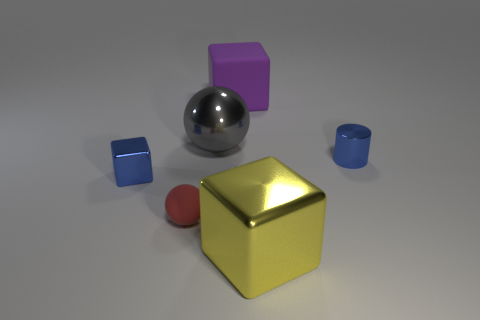Is the color of the shiny cylinder the same as the tiny metallic cube?
Your answer should be very brief. Yes. Are there an equal number of small red spheres that are right of the large yellow object and tiny red rubber objects?
Provide a short and direct response. No. Are there any big metallic spheres in front of the gray metal thing?
Your response must be concise. No. There is a large yellow metal thing; does it have the same shape as the tiny metallic thing that is on the right side of the big purple cube?
Your answer should be very brief. No. The large object that is the same material as the tiny red thing is what color?
Your answer should be very brief. Purple. What color is the small metal cylinder?
Your answer should be very brief. Blue. Does the blue block have the same material as the big yellow cube to the right of the metal ball?
Your response must be concise. Yes. How many objects are in front of the blue block and behind the big yellow shiny block?
Your answer should be very brief. 1. What shape is the red rubber object that is the same size as the blue shiny block?
Offer a very short reply. Sphere. There is a large metallic thing that is on the right side of the thing behind the large gray ball; is there a blue metal object right of it?
Your answer should be compact. Yes. 